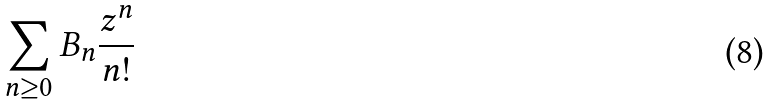<formula> <loc_0><loc_0><loc_500><loc_500>\sum _ { n \geq 0 } B _ { n } { \frac { z ^ { n } } { n ! } }</formula> 